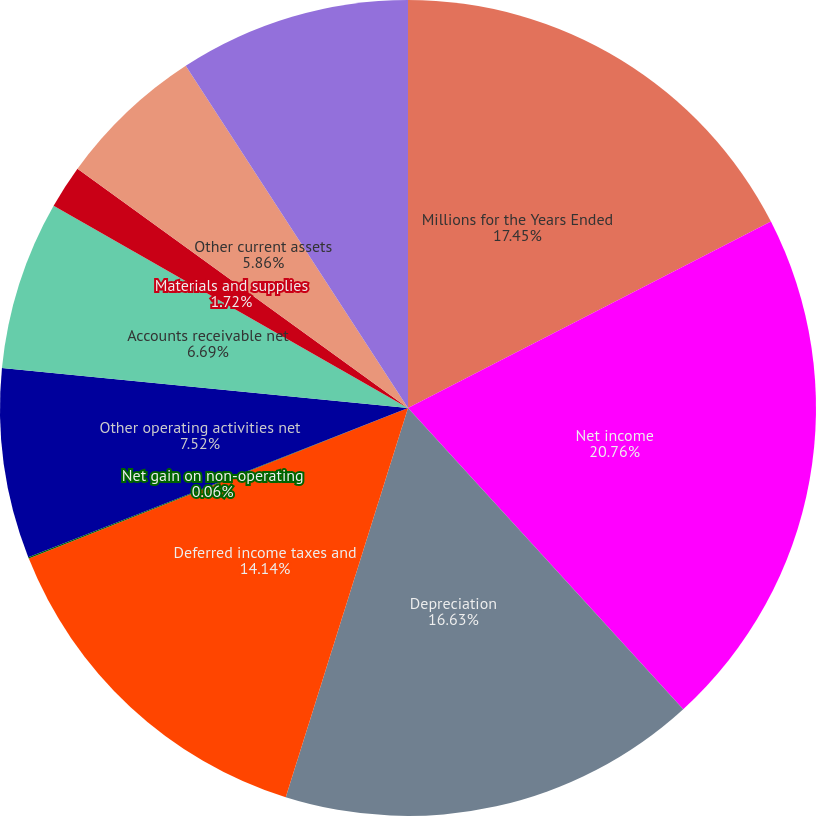Convert chart to OTSL. <chart><loc_0><loc_0><loc_500><loc_500><pie_chart><fcel>Millions for the Years Ended<fcel>Net income<fcel>Depreciation<fcel>Deferred income taxes and<fcel>Net gain on non-operating<fcel>Other operating activities net<fcel>Accounts receivable net<fcel>Materials and supplies<fcel>Other current assets<fcel>Accounts payable and other<nl><fcel>17.45%<fcel>20.77%<fcel>16.63%<fcel>14.14%<fcel>0.06%<fcel>7.52%<fcel>6.69%<fcel>1.72%<fcel>5.86%<fcel>9.17%<nl></chart> 